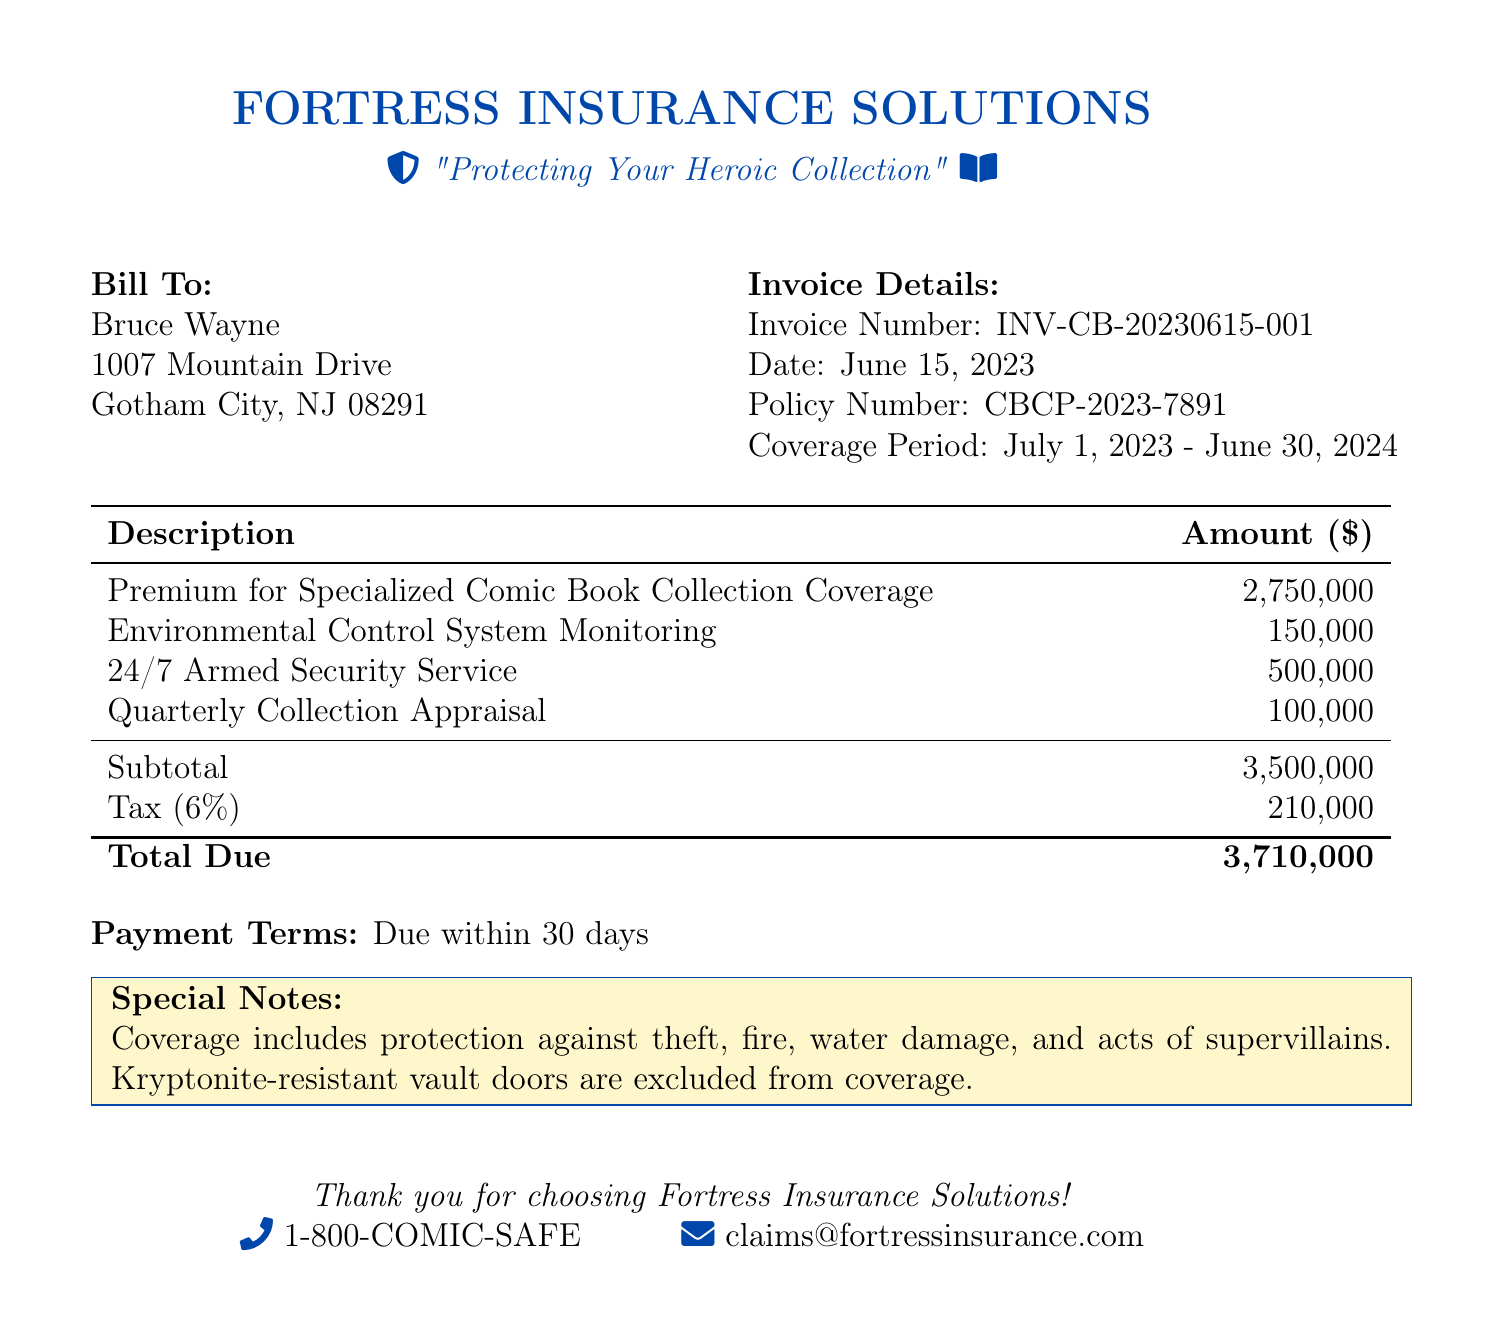What is the invoice number? The invoice number is a unique identifier for the bill, which is listed in the document.
Answer: INV-CB-20230615-001 Who is the bill addressed to? The document includes a section specifying the recipient of the bill.
Answer: Bruce Wayne What is the total due? This value is presented at the bottom of the invoice, summarizing the total charges.
Answer: 3,710,000 What is the coverage period? The coverage period indicates the duration of insurance protection provided.
Answer: July 1, 2023 - June 30, 2024 What is included in the coverage? The document details what types of losses are protected under the insurance policy.
Answer: Theft, fire, water damage, and acts of supervillains What is the tax rate applied? The tax percentage is mentioned in the calculation of the total due in the bill.
Answer: 6% What service costs the most? This question requires comparing the amounts listed next to each service provided in the invoice.
Answer: Premium for Specialized Comic Book Collection Coverage What are the payment terms? The document states the conditions under which the payment should be made.
Answer: Due within 30 days What is excluded from coverage? The document specifies one item that is not covered by the insurance policy.
Answer: Kryptonite-resistant vault doors 